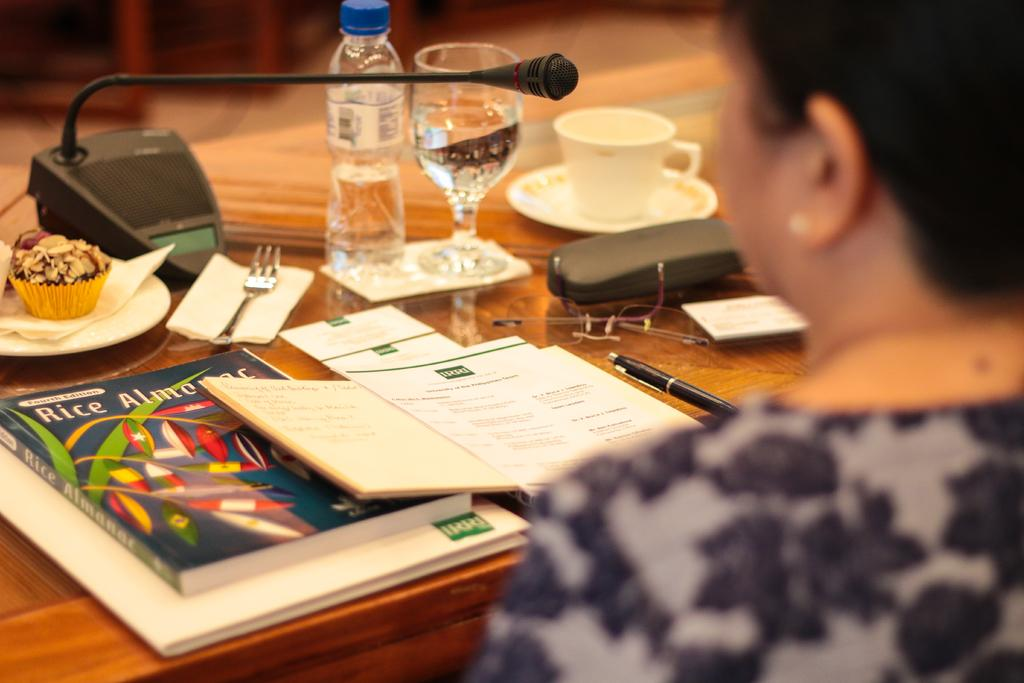<image>
Describe the image concisely. Woman reading something with the letters "IRRI" in green on top. 